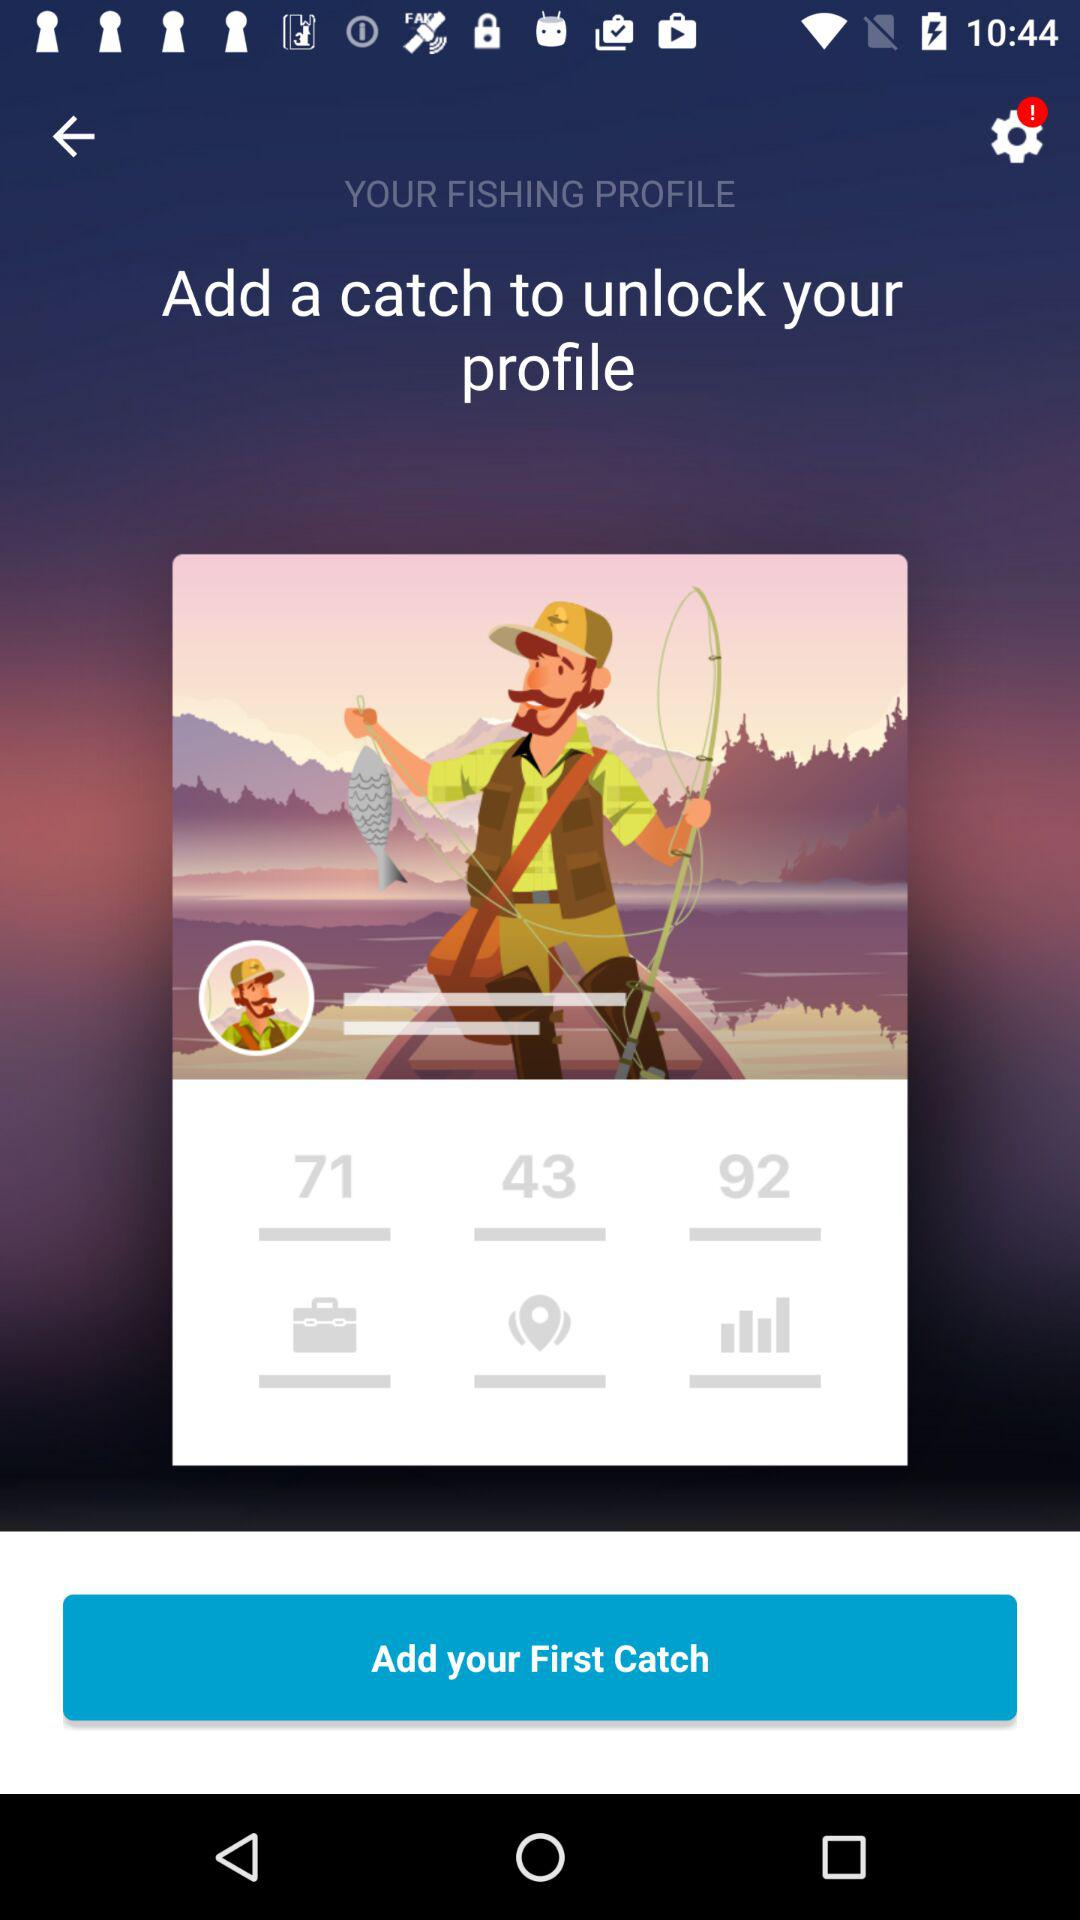What is the number of new notification in settings?
When the provided information is insufficient, respond with <no answer>. <no answer> 